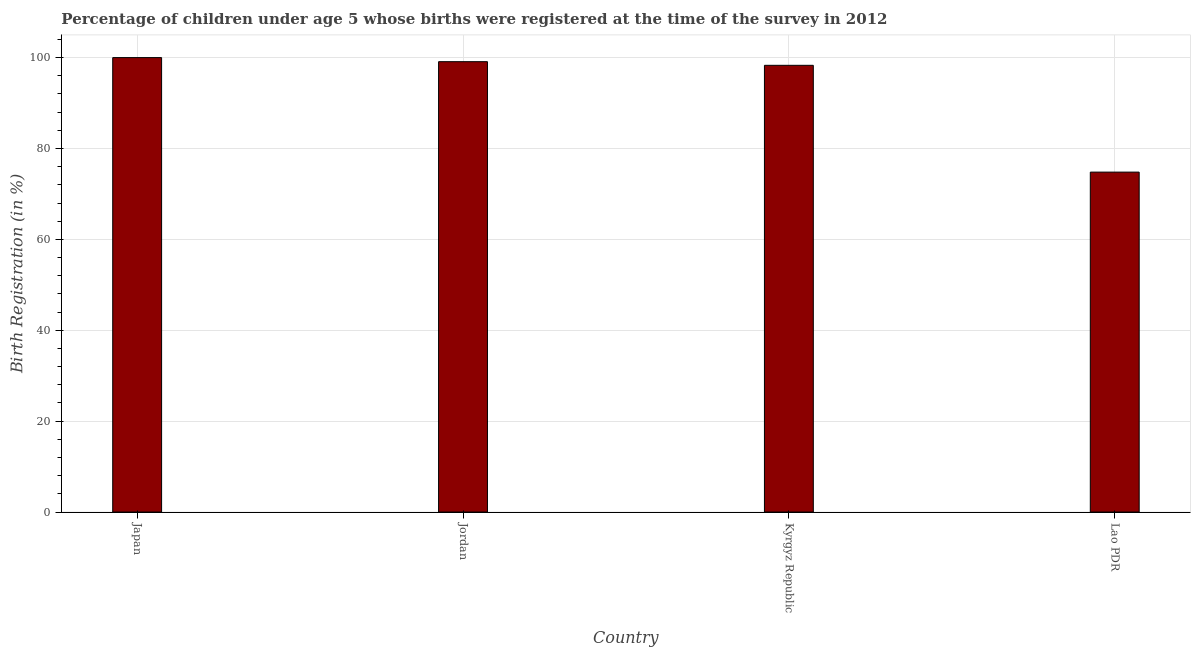What is the title of the graph?
Offer a terse response. Percentage of children under age 5 whose births were registered at the time of the survey in 2012. What is the label or title of the Y-axis?
Provide a succinct answer. Birth Registration (in %). What is the birth registration in Kyrgyz Republic?
Give a very brief answer. 98.3. Across all countries, what is the maximum birth registration?
Provide a succinct answer. 100. Across all countries, what is the minimum birth registration?
Provide a succinct answer. 74.8. In which country was the birth registration minimum?
Your answer should be compact. Lao PDR. What is the sum of the birth registration?
Provide a short and direct response. 372.2. What is the average birth registration per country?
Offer a very short reply. 93.05. What is the median birth registration?
Offer a terse response. 98.7. What is the difference between the highest and the second highest birth registration?
Keep it short and to the point. 0.9. Is the sum of the birth registration in Japan and Lao PDR greater than the maximum birth registration across all countries?
Your answer should be very brief. Yes. What is the difference between the highest and the lowest birth registration?
Ensure brevity in your answer.  25.2. In how many countries, is the birth registration greater than the average birth registration taken over all countries?
Make the answer very short. 3. How many bars are there?
Provide a succinct answer. 4. Are all the bars in the graph horizontal?
Provide a succinct answer. No. How many countries are there in the graph?
Provide a short and direct response. 4. What is the Birth Registration (in %) of Japan?
Give a very brief answer. 100. What is the Birth Registration (in %) in Jordan?
Keep it short and to the point. 99.1. What is the Birth Registration (in %) in Kyrgyz Republic?
Offer a very short reply. 98.3. What is the Birth Registration (in %) of Lao PDR?
Make the answer very short. 74.8. What is the difference between the Birth Registration (in %) in Japan and Lao PDR?
Your answer should be very brief. 25.2. What is the difference between the Birth Registration (in %) in Jordan and Lao PDR?
Your answer should be very brief. 24.3. What is the ratio of the Birth Registration (in %) in Japan to that in Kyrgyz Republic?
Offer a terse response. 1.02. What is the ratio of the Birth Registration (in %) in Japan to that in Lao PDR?
Keep it short and to the point. 1.34. What is the ratio of the Birth Registration (in %) in Jordan to that in Lao PDR?
Offer a terse response. 1.32. What is the ratio of the Birth Registration (in %) in Kyrgyz Republic to that in Lao PDR?
Your answer should be compact. 1.31. 